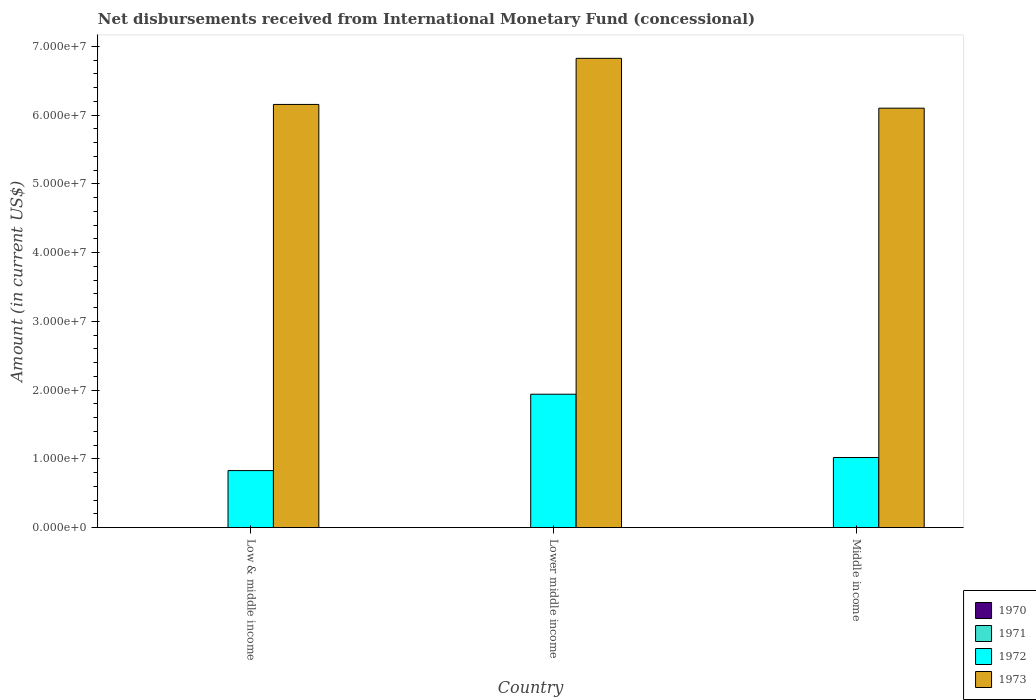How many groups of bars are there?
Your answer should be very brief. 3. Are the number of bars on each tick of the X-axis equal?
Your answer should be very brief. Yes. How many bars are there on the 1st tick from the left?
Offer a very short reply. 2. How many bars are there on the 1st tick from the right?
Make the answer very short. 2. What is the label of the 2nd group of bars from the left?
Your answer should be very brief. Lower middle income. Across all countries, what is the maximum amount of disbursements received from International Monetary Fund in 1973?
Give a very brief answer. 6.83e+07. In which country was the amount of disbursements received from International Monetary Fund in 1973 maximum?
Your answer should be compact. Lower middle income. What is the total amount of disbursements received from International Monetary Fund in 1972 in the graph?
Make the answer very short. 3.79e+07. What is the difference between the amount of disbursements received from International Monetary Fund in 1973 in Low & middle income and that in Middle income?
Your response must be concise. 5.46e+05. What is the difference between the amount of disbursements received from International Monetary Fund in 1970 in Low & middle income and the amount of disbursements received from International Monetary Fund in 1973 in Middle income?
Your answer should be compact. -6.10e+07. What is the average amount of disbursements received from International Monetary Fund in 1972 per country?
Provide a short and direct response. 1.26e+07. What is the difference between the amount of disbursements received from International Monetary Fund of/in 1973 and amount of disbursements received from International Monetary Fund of/in 1972 in Middle income?
Your response must be concise. 5.08e+07. In how many countries, is the amount of disbursements received from International Monetary Fund in 1973 greater than 2000000 US$?
Provide a succinct answer. 3. What is the ratio of the amount of disbursements received from International Monetary Fund in 1972 in Low & middle income to that in Lower middle income?
Offer a terse response. 0.43. Is the amount of disbursements received from International Monetary Fund in 1972 in Low & middle income less than that in Middle income?
Your answer should be very brief. Yes. What is the difference between the highest and the second highest amount of disbursements received from International Monetary Fund in 1972?
Give a very brief answer. 9.21e+06. Is the sum of the amount of disbursements received from International Monetary Fund in 1972 in Lower middle income and Middle income greater than the maximum amount of disbursements received from International Monetary Fund in 1970 across all countries?
Provide a short and direct response. Yes. Are all the bars in the graph horizontal?
Make the answer very short. No. How many countries are there in the graph?
Your answer should be very brief. 3. Are the values on the major ticks of Y-axis written in scientific E-notation?
Provide a succinct answer. Yes. Does the graph contain any zero values?
Provide a short and direct response. Yes. How many legend labels are there?
Provide a succinct answer. 4. How are the legend labels stacked?
Keep it short and to the point. Vertical. What is the title of the graph?
Provide a succinct answer. Net disbursements received from International Monetary Fund (concessional). Does "1960" appear as one of the legend labels in the graph?
Ensure brevity in your answer.  No. What is the label or title of the Y-axis?
Make the answer very short. Amount (in current US$). What is the Amount (in current US$) in 1970 in Low & middle income?
Make the answer very short. 0. What is the Amount (in current US$) of 1971 in Low & middle income?
Your response must be concise. 0. What is the Amount (in current US$) of 1972 in Low & middle income?
Ensure brevity in your answer.  8.30e+06. What is the Amount (in current US$) in 1973 in Low & middle income?
Your answer should be compact. 6.16e+07. What is the Amount (in current US$) in 1971 in Lower middle income?
Your answer should be very brief. 0. What is the Amount (in current US$) of 1972 in Lower middle income?
Your response must be concise. 1.94e+07. What is the Amount (in current US$) of 1973 in Lower middle income?
Provide a short and direct response. 6.83e+07. What is the Amount (in current US$) in 1971 in Middle income?
Provide a short and direct response. 0. What is the Amount (in current US$) in 1972 in Middle income?
Your answer should be very brief. 1.02e+07. What is the Amount (in current US$) of 1973 in Middle income?
Ensure brevity in your answer.  6.10e+07. Across all countries, what is the maximum Amount (in current US$) in 1972?
Give a very brief answer. 1.94e+07. Across all countries, what is the maximum Amount (in current US$) of 1973?
Provide a succinct answer. 6.83e+07. Across all countries, what is the minimum Amount (in current US$) of 1972?
Offer a very short reply. 8.30e+06. Across all countries, what is the minimum Amount (in current US$) of 1973?
Keep it short and to the point. 6.10e+07. What is the total Amount (in current US$) in 1970 in the graph?
Provide a succinct answer. 0. What is the total Amount (in current US$) of 1971 in the graph?
Provide a short and direct response. 0. What is the total Amount (in current US$) of 1972 in the graph?
Your answer should be very brief. 3.79e+07. What is the total Amount (in current US$) of 1973 in the graph?
Provide a short and direct response. 1.91e+08. What is the difference between the Amount (in current US$) in 1972 in Low & middle income and that in Lower middle income?
Your response must be concise. -1.11e+07. What is the difference between the Amount (in current US$) in 1973 in Low & middle income and that in Lower middle income?
Provide a short and direct response. -6.70e+06. What is the difference between the Amount (in current US$) in 1972 in Low & middle income and that in Middle income?
Your response must be concise. -1.90e+06. What is the difference between the Amount (in current US$) in 1973 in Low & middle income and that in Middle income?
Your answer should be very brief. 5.46e+05. What is the difference between the Amount (in current US$) in 1972 in Lower middle income and that in Middle income?
Offer a very short reply. 9.21e+06. What is the difference between the Amount (in current US$) in 1973 in Lower middle income and that in Middle income?
Ensure brevity in your answer.  7.25e+06. What is the difference between the Amount (in current US$) in 1972 in Low & middle income and the Amount (in current US$) in 1973 in Lower middle income?
Keep it short and to the point. -6.00e+07. What is the difference between the Amount (in current US$) in 1972 in Low & middle income and the Amount (in current US$) in 1973 in Middle income?
Your response must be concise. -5.27e+07. What is the difference between the Amount (in current US$) of 1972 in Lower middle income and the Amount (in current US$) of 1973 in Middle income?
Keep it short and to the point. -4.16e+07. What is the average Amount (in current US$) in 1972 per country?
Give a very brief answer. 1.26e+07. What is the average Amount (in current US$) of 1973 per country?
Your response must be concise. 6.36e+07. What is the difference between the Amount (in current US$) in 1972 and Amount (in current US$) in 1973 in Low & middle income?
Provide a short and direct response. -5.33e+07. What is the difference between the Amount (in current US$) in 1972 and Amount (in current US$) in 1973 in Lower middle income?
Your answer should be compact. -4.89e+07. What is the difference between the Amount (in current US$) of 1972 and Amount (in current US$) of 1973 in Middle income?
Offer a terse response. -5.08e+07. What is the ratio of the Amount (in current US$) in 1972 in Low & middle income to that in Lower middle income?
Offer a terse response. 0.43. What is the ratio of the Amount (in current US$) of 1973 in Low & middle income to that in Lower middle income?
Keep it short and to the point. 0.9. What is the ratio of the Amount (in current US$) in 1972 in Low & middle income to that in Middle income?
Your response must be concise. 0.81. What is the ratio of the Amount (in current US$) in 1973 in Low & middle income to that in Middle income?
Your answer should be very brief. 1.01. What is the ratio of the Amount (in current US$) of 1972 in Lower middle income to that in Middle income?
Provide a succinct answer. 1.9. What is the ratio of the Amount (in current US$) of 1973 in Lower middle income to that in Middle income?
Your answer should be compact. 1.12. What is the difference between the highest and the second highest Amount (in current US$) of 1972?
Provide a short and direct response. 9.21e+06. What is the difference between the highest and the second highest Amount (in current US$) of 1973?
Make the answer very short. 6.70e+06. What is the difference between the highest and the lowest Amount (in current US$) in 1972?
Your answer should be very brief. 1.11e+07. What is the difference between the highest and the lowest Amount (in current US$) in 1973?
Provide a succinct answer. 7.25e+06. 